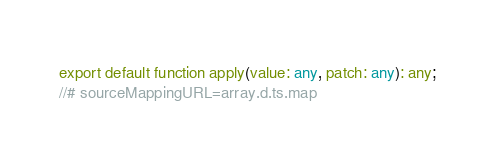<code> <loc_0><loc_0><loc_500><loc_500><_TypeScript_>export default function apply(value: any, patch: any): any;
//# sourceMappingURL=array.d.ts.map</code> 